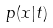<formula> <loc_0><loc_0><loc_500><loc_500>p ( x | t )</formula> 